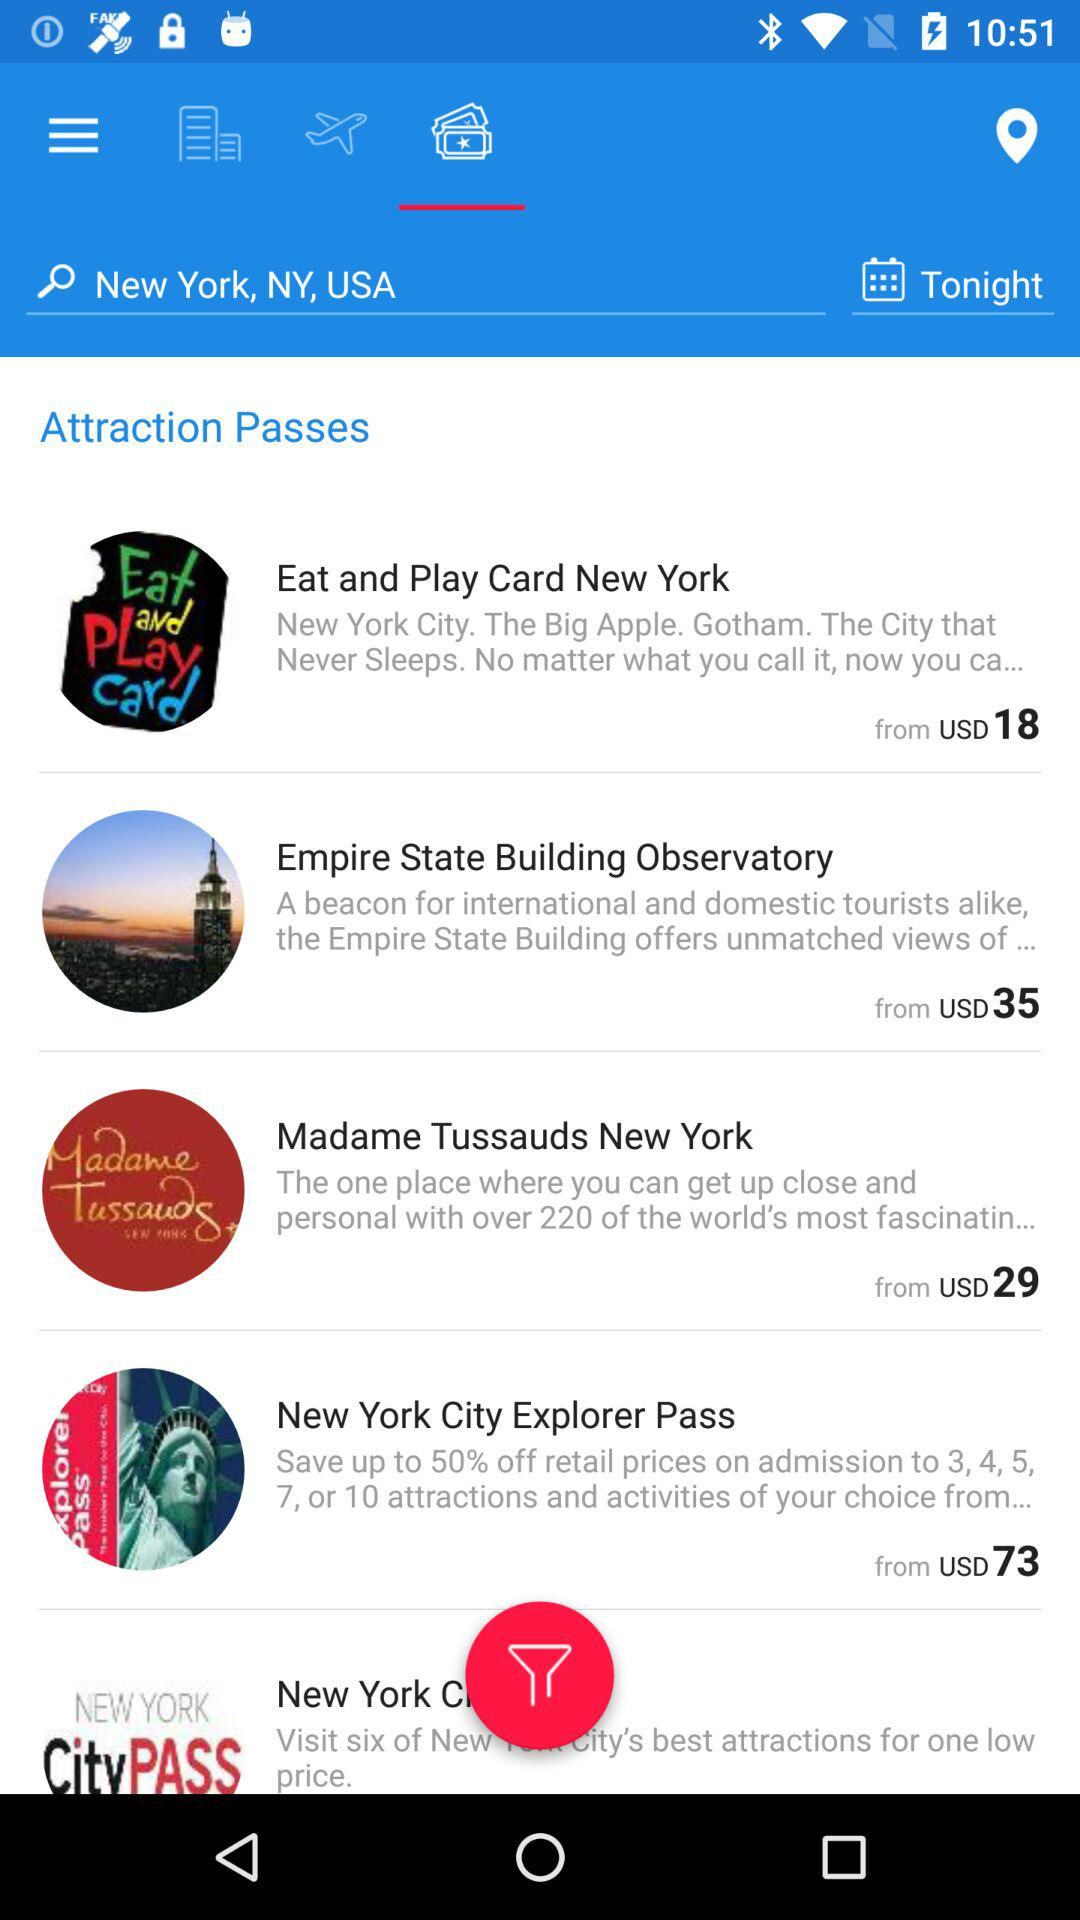What is the starting price of the "New York City Explorer Pass"? The starting price of the "New York City Explorer Pass" is USD 73. 